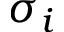<formula> <loc_0><loc_0><loc_500><loc_500>\sigma _ { i }</formula> 